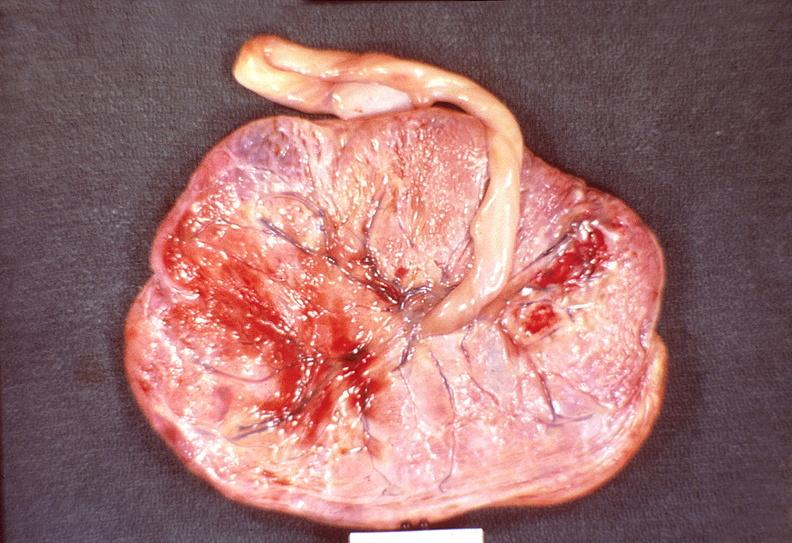what does this image show?
Answer the question using a single word or phrase. Placenta 